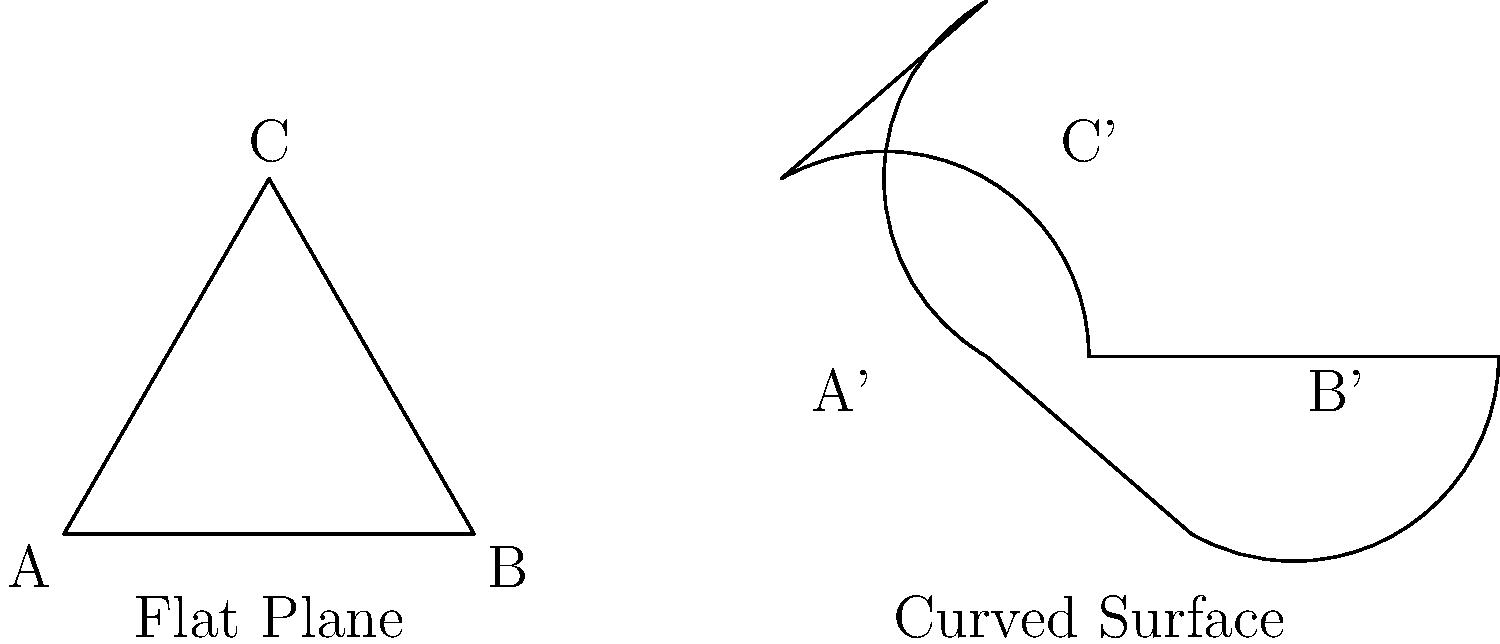In the diagram above, two triangles are shown: one on a flat plane and another on a curved surface. If the angles of the flat plane triangle ABC are 60°, 60°, and 60°, what is the sum of the angles in the curved surface triangle A'B'C'? Explain why this difference occurs and how it relates to Non-Euclidean Geometry. To understand the difference between the sum of angles in these triangles, let's follow these steps:

1. Flat plane triangle (Euclidean Geometry):
   - In Euclidean geometry, the sum of angles in a triangle is always 180°.
   - For triangle ABC: $60° + 60° + 60° = 180°$

2. Curved surface triangle (Non-Euclidean Geometry):
   - On a curved surface, the sum of angles in a triangle can exceed 180°.
   - This is because the surface's curvature affects the geometry of shapes drawn on it.

3. Difference in geometry:
   - The curved surface represents a sphere-like geometry (elliptic geometry).
   - In elliptic geometry, straight lines are represented by great circles.
   - The triangle A'B'C' is formed by arcs of great circles, which causes the angles to be larger.

4. Sum of angles on a curved surface:
   - The sum of angles in a triangle on a curved surface is given by:
     $180° + \alpha A$, where $A$ is the area of the triangle and $\alpha$ is the Gaussian curvature of the surface.
   - For a sphere with radius $R$, the Gaussian curvature $\alpha = \frac{1}{R^2}$

5. Result:
   - The sum of angles in triangle A'B'C' will be greater than 180°.
   - The exact sum depends on the curvature of the surface and the size of the triangle.

This difference illustrates a fundamental principle of Non-Euclidean Geometry: the properties of geometric shapes can vary depending on the nature of the space in which they are drawn.
Answer: $>180°$ 